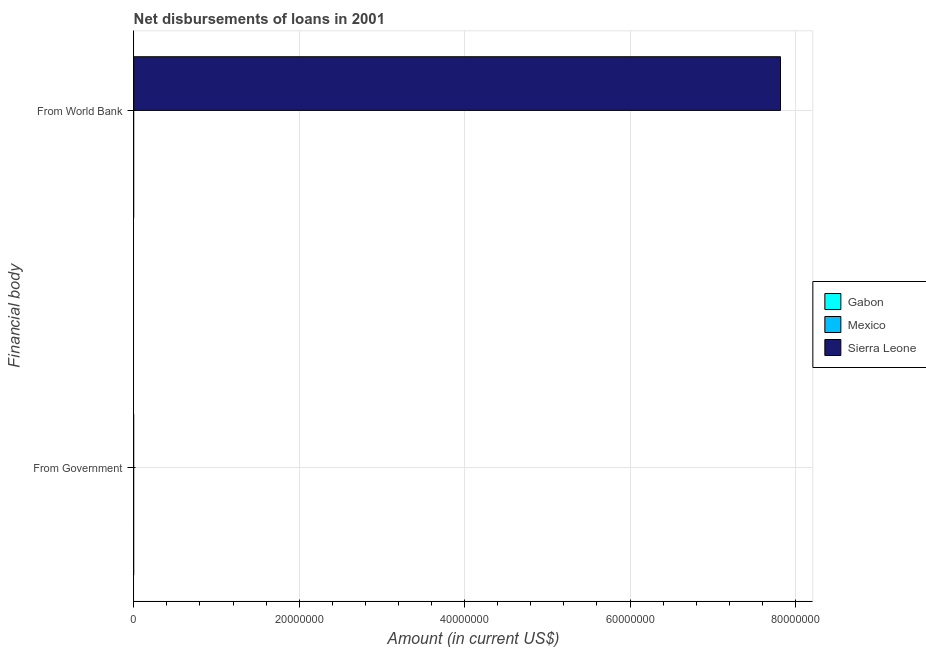How many different coloured bars are there?
Provide a short and direct response. 1. Are the number of bars per tick equal to the number of legend labels?
Your response must be concise. No. How many bars are there on the 2nd tick from the top?
Keep it short and to the point. 0. How many bars are there on the 2nd tick from the bottom?
Ensure brevity in your answer.  1. What is the label of the 2nd group of bars from the top?
Ensure brevity in your answer.  From Government. What is the net disbursements of loan from world bank in Mexico?
Offer a terse response. 0. Across all countries, what is the maximum net disbursements of loan from world bank?
Ensure brevity in your answer.  7.82e+07. Across all countries, what is the minimum net disbursements of loan from government?
Keep it short and to the point. 0. In which country was the net disbursements of loan from world bank maximum?
Keep it short and to the point. Sierra Leone. What is the total net disbursements of loan from world bank in the graph?
Your response must be concise. 7.82e+07. What is the difference between the net disbursements of loan from government in Sierra Leone and the net disbursements of loan from world bank in Mexico?
Ensure brevity in your answer.  0. What is the average net disbursements of loan from world bank per country?
Keep it short and to the point. 2.61e+07. In how many countries, is the net disbursements of loan from government greater than 68000000 US$?
Keep it short and to the point. 0. Are all the bars in the graph horizontal?
Ensure brevity in your answer.  Yes. How many countries are there in the graph?
Provide a succinct answer. 3. What is the difference between two consecutive major ticks on the X-axis?
Give a very brief answer. 2.00e+07. Are the values on the major ticks of X-axis written in scientific E-notation?
Give a very brief answer. No. Does the graph contain any zero values?
Your response must be concise. Yes. How many legend labels are there?
Provide a short and direct response. 3. How are the legend labels stacked?
Your answer should be compact. Vertical. What is the title of the graph?
Provide a short and direct response. Net disbursements of loans in 2001. What is the label or title of the Y-axis?
Your answer should be compact. Financial body. What is the Amount (in current US$) in Sierra Leone in From World Bank?
Keep it short and to the point. 7.82e+07. Across all Financial body, what is the maximum Amount (in current US$) of Sierra Leone?
Provide a short and direct response. 7.82e+07. Across all Financial body, what is the minimum Amount (in current US$) in Sierra Leone?
Offer a very short reply. 0. What is the total Amount (in current US$) in Gabon in the graph?
Give a very brief answer. 0. What is the total Amount (in current US$) in Sierra Leone in the graph?
Provide a short and direct response. 7.82e+07. What is the average Amount (in current US$) in Sierra Leone per Financial body?
Your answer should be compact. 3.91e+07. What is the difference between the highest and the lowest Amount (in current US$) in Sierra Leone?
Make the answer very short. 7.82e+07. 